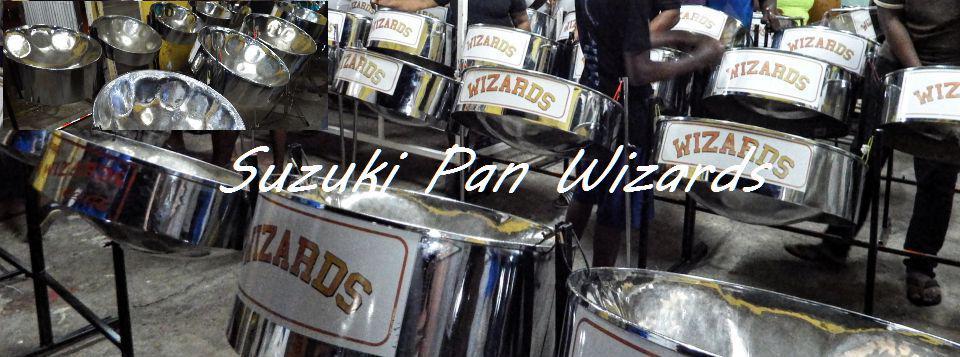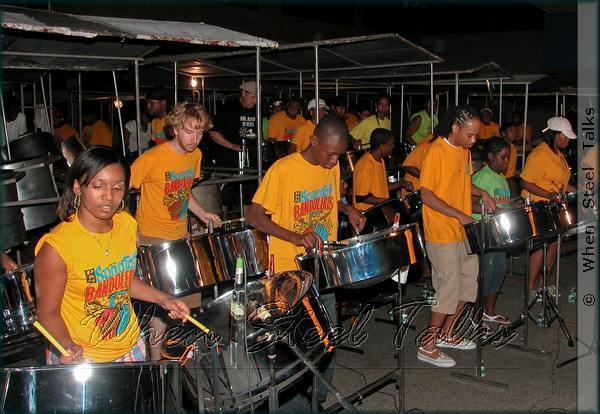The first image is the image on the left, the second image is the image on the right. Examine the images to the left and right. Is the description "A drummer is wearing a hat." accurate? Answer yes or no. Yes. 